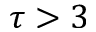Convert formula to latex. <formula><loc_0><loc_0><loc_500><loc_500>\tau > 3</formula> 